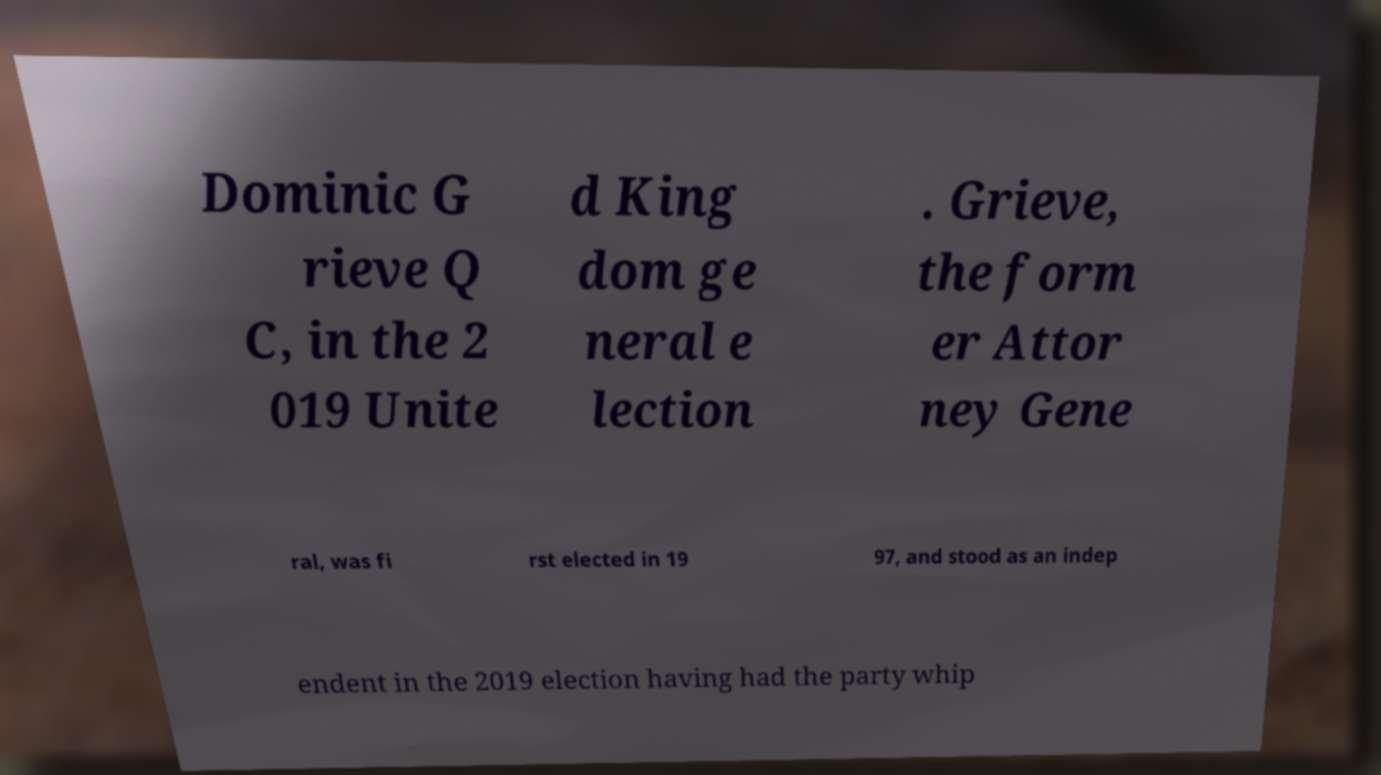What messages or text are displayed in this image? I need them in a readable, typed format. Dominic G rieve Q C, in the 2 019 Unite d King dom ge neral e lection . Grieve, the form er Attor ney Gene ral, was fi rst elected in 19 97, and stood as an indep endent in the 2019 election having had the party whip 